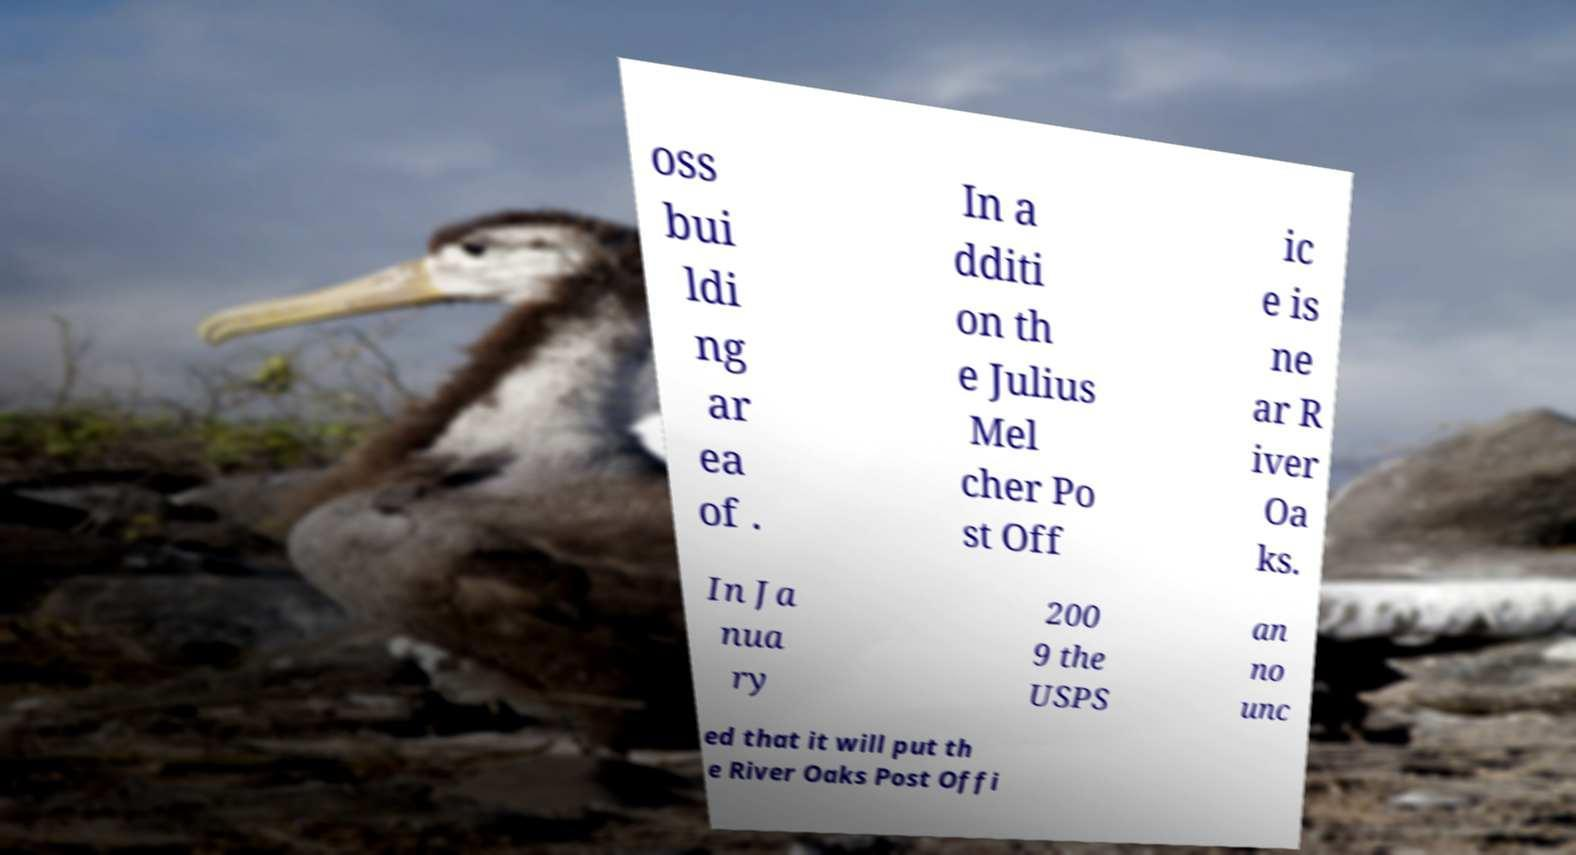Can you accurately transcribe the text from the provided image for me? oss bui ldi ng ar ea of . In a dditi on th e Julius Mel cher Po st Off ic e is ne ar R iver Oa ks. In Ja nua ry 200 9 the USPS an no unc ed that it will put th e River Oaks Post Offi 